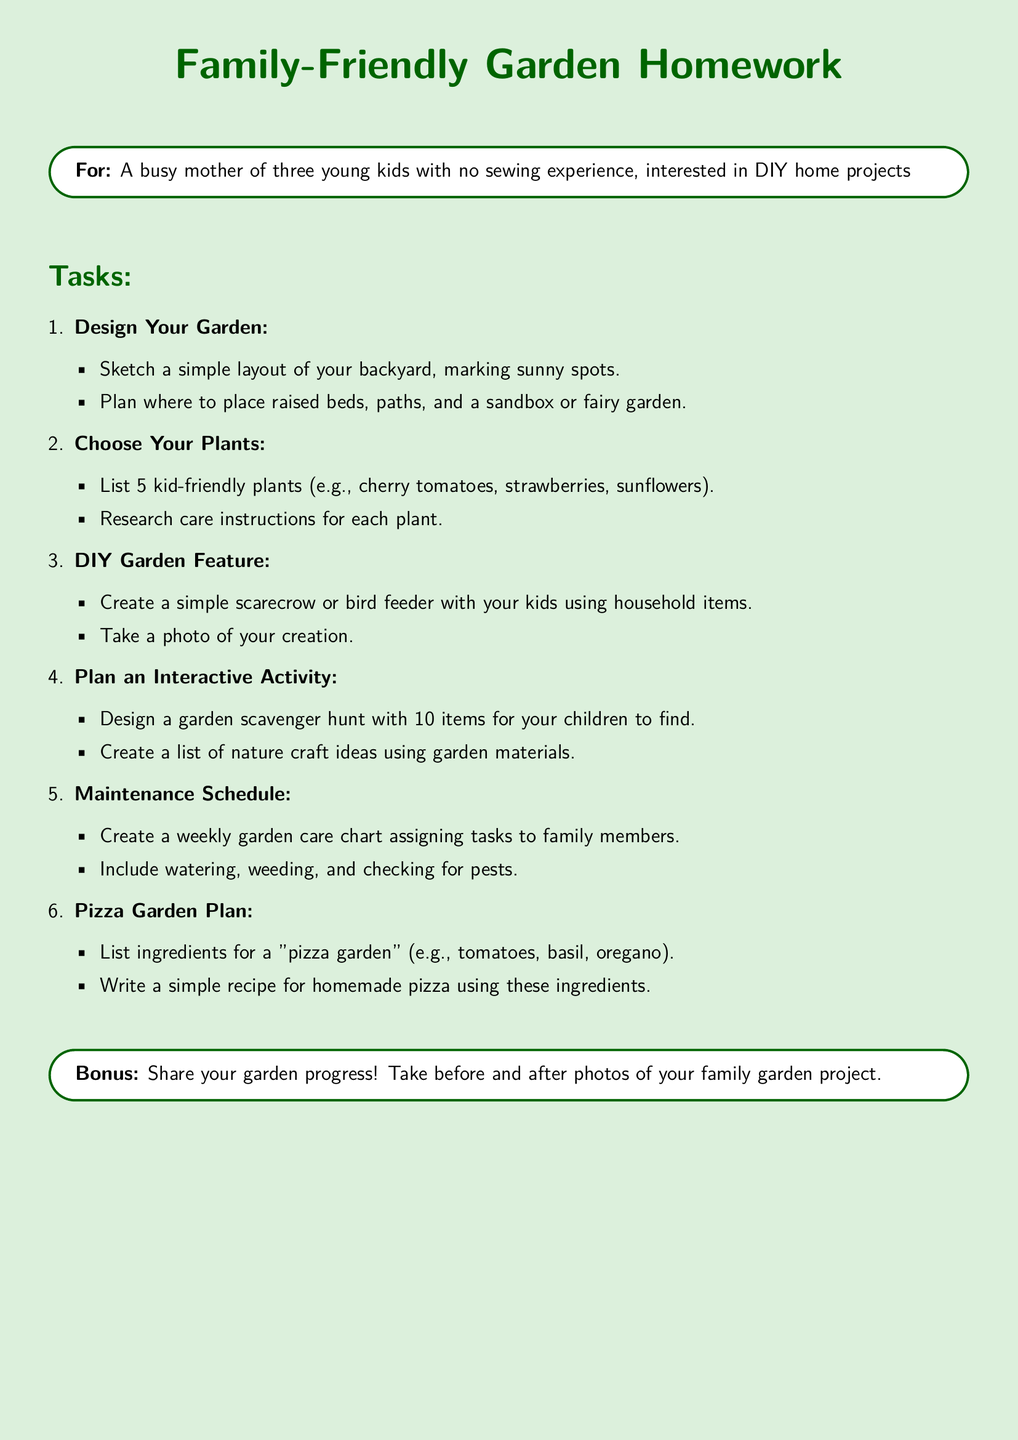what is the title of the homework? The title of the homework clearly states the project focus as "Family-Friendly Garden Homework."
Answer: Family-Friendly Garden Homework what is one type of plant you can choose? The document lists kid-friendly plants, which can include cherry tomatoes.
Answer: cherry tomatoes how many interactive activity items should you include in a scavenger hunt? The document specifies that you should design a garden scavenger hunt with 10 items.
Answer: 10 what are two tasks in the "Choose Your Plants" section? This section includes listing 5 kid-friendly plants and researching care instructions.
Answer: list 5 kid-friendly plants, research care instructions what is a DIY garden feature mentioned in the tasks? The homework suggests creating a simple scarecrow as a DIY garden feature.
Answer: scarecrow how many ingredients should be listed for a pizza garden? The document specifies to list ingredients for a "pizza garden."
Answer: 3 who is the intended audience for this homework? The intended audience is described as "A busy mother of three young kids with no sewing experience."
Answer: A busy mother of three young kids with no sewing experience what should you include in the maintenance schedule? The maintenance schedule should include tasks like watering and weeding.
Answer: watering, weeding what is the bonus task in the document? The bonus task encourages sharing garden progress and taking before and after photos.
Answer: Share your garden progress! 